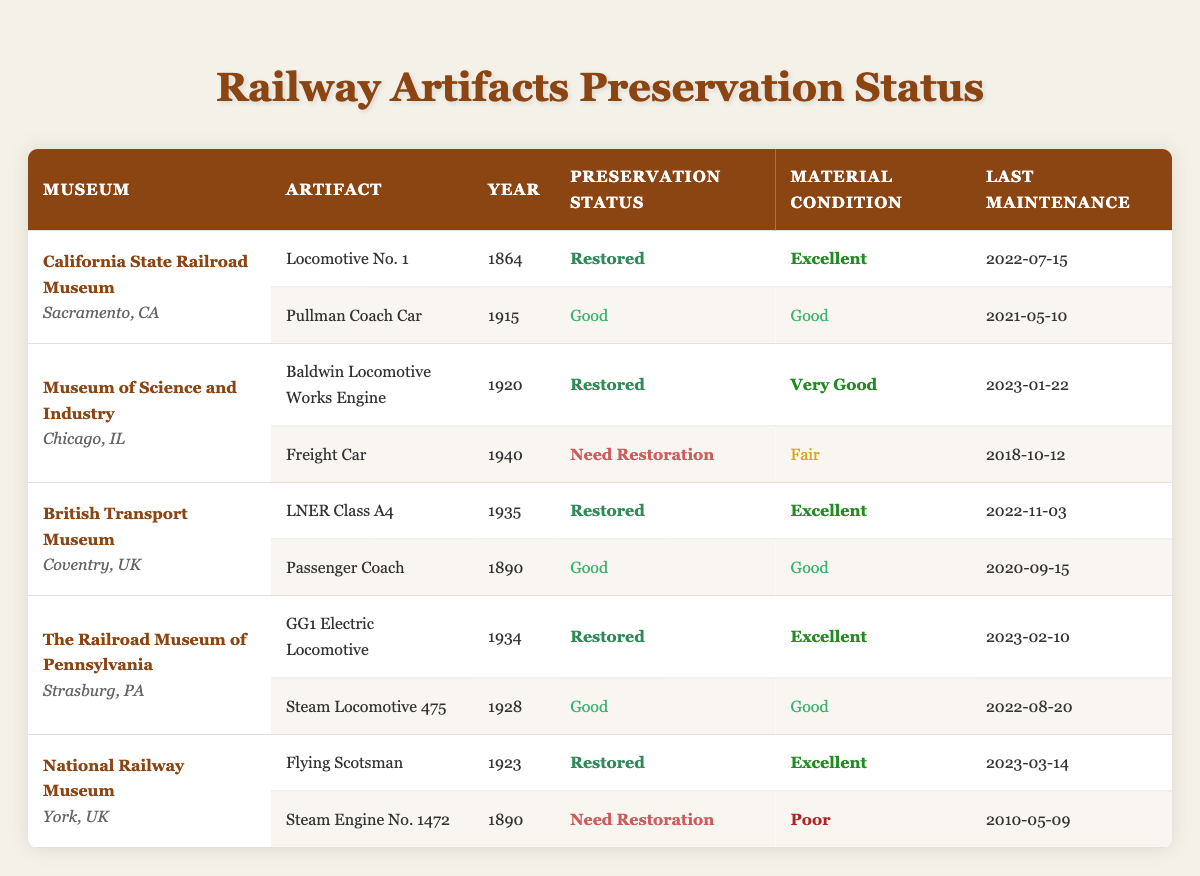What is the preservation status of Locomotive No. 1? Locomotive No. 1 is listed under the California State Railroad Museum with a preservation status of "Restored."
Answer: Restored Which artifact was last maintained on 2023-03-14? The artifact maintained on 2023-03-14 is the Flying Scotsman from the National Railway Museum.
Answer: Flying Scotsman How many artifacts need restoration across all museums? Only two artifacts need restoration: the Freight Car at the Museum of Science and Industry and the Steam Engine No. 1472 at the National Railway Museum.
Answer: 2 What is the material condition of the Passenger Coach? The Passenger Coach from the British Transport Museum has a material condition classified as "Good."
Answer: Good Which museum has the oldest artifact, and what is the year of construction? The California State Railroad Museum has the oldest artifact, Locomotive No. 1, constructed in 1864.
Answer: California State Railroad Museum, 1864 Is there any artifact that is both restored and has an excellent material condition? Yes, multiple artifacts are restored and have excellent material conditions, such as Locomotive No. 1, LNER Class A4, GG1 Electric Locomotive, and Flying Scotsman.
Answer: Yes What is the average year of construction for the artifacts listed? The years of construction are: 1864, 1915, 1920, 1940, 1935, 1890, 1934, 1928, 1923, 1890. The sum total is 19,760, and there are 10 artifacts, leading to an average of 1,976.
Answer: 1976 Which artifacts have a preservation status of "Good"? The artifacts with a preservation status of "Good" are the Pullman Coach Car, Passenger Coach, and Steam Locomotive 475.
Answer: 3 What are the locations of museums that have restored artifacts? All museums listed have restored artifacts: California State Railroad Museum, Museum of Science and Industry, British Transport Museum, The Railroad Museum of Pennsylvania, and National Railway Museum.
Answer: 5 locations Which artifact was built in 1940 and what is its preservation status? The Freight Car was built in 1940 and its preservation status is "Need Restoration."
Answer: Freight Car, Need Restoration 